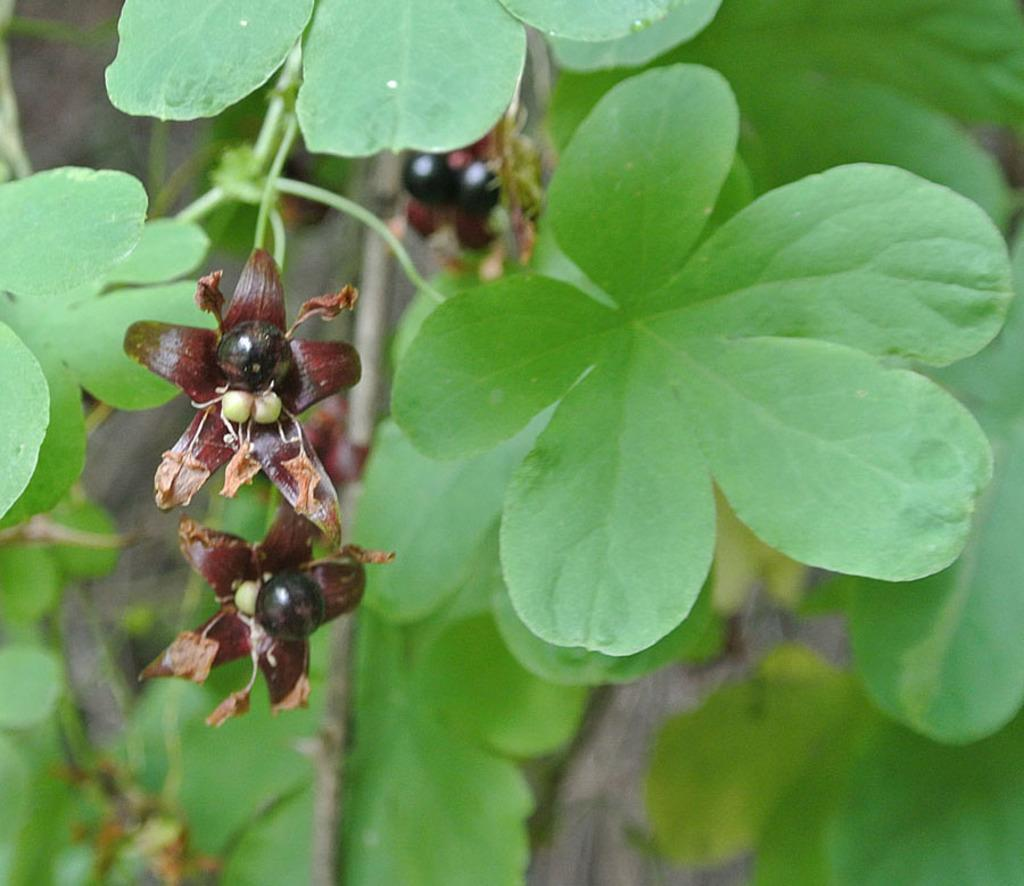What type of living organism is present in the image? There is a plant in the image. What are the main features of the plant? The plant has leaves, brown-colored flowers, and seeds. What type of government can be seen governing the lake in the image? There is no lake or government present in the image; it features a plant with leaves, brown-colored flowers, and seeds. 